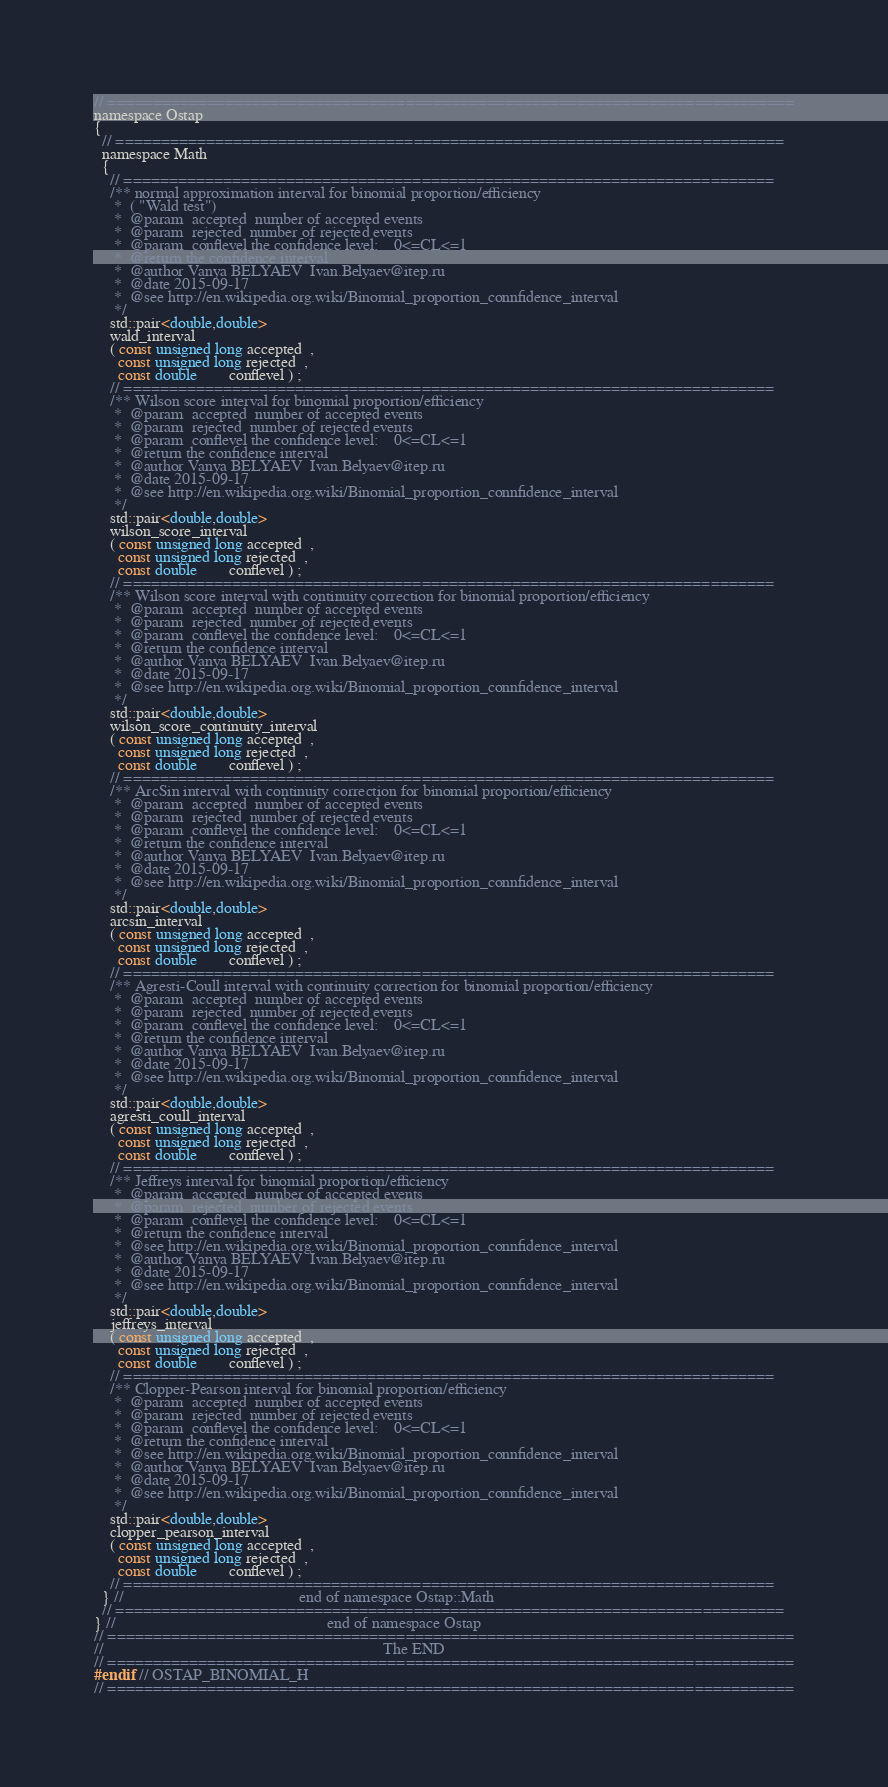Convert code to text. <code><loc_0><loc_0><loc_500><loc_500><_C_>// ============================================================================
namespace Ostap
{
  // ==========================================================================
  namespace Math
  {
    // ========================================================================
    /** normal approximation interval for binomial proportion/efficiency 
     *  ( "Wald test")
     *  @param  accepted  number of accepted events
     *  @param  rejected  number of rejected events
     *  @param  conflevel the confidence level:    0<=CL<=1 
     *  @return the confidence interval 
     *  @author Vanya BELYAEV  Ivan.Belyaev@itep.ru
     *  @date 2015-09-17
     *  @see http://en.wikipedia.org.wiki/Binomial_proportion_connfidence_interval
     */
    std::pair<double,double>
    wald_interval
    ( const unsigned long accepted  ,
      const unsigned long rejected  ,
      const double        conflevel ) ;
    // ========================================================================
    /** Wilson score interval for binomial proportion/efficiency 
     *  @param  accepted  number of accepted events
     *  @param  rejected  number of rejected events
     *  @param  conflevel the confidence level:    0<=CL<=1 
     *  @return the confidence interval 
     *  @author Vanya BELYAEV  Ivan.Belyaev@itep.ru
     *  @date 2015-09-17
     *  @see http://en.wikipedia.org.wiki/Binomial_proportion_connfidence_interval
     */
    std::pair<double,double>
    wilson_score_interval
    ( const unsigned long accepted  ,
      const unsigned long rejected  ,
      const double        conflevel ) ;
    // ========================================================================
    /** Wilson score interval with continuity correction for binomial proportion/efficiency 
     *  @param  accepted  number of accepted events
     *  @param  rejected  number of rejected events
     *  @param  conflevel the confidence level:    0<=CL<=1 
     *  @return the confidence interval 
     *  @author Vanya BELYAEV  Ivan.Belyaev@itep.ru
     *  @date 2015-09-17
     *  @see http://en.wikipedia.org.wiki/Binomial_proportion_connfidence_interval
     */
    std::pair<double,double>
    wilson_score_continuity_interval
    ( const unsigned long accepted  ,
      const unsigned long rejected  ,
      const double        conflevel ) ;
    // ========================================================================
    /** ArcSin interval with continuity correction for binomial proportion/efficiency 
     *  @param  accepted  number of accepted events
     *  @param  rejected  number of rejected events
     *  @param  conflevel the confidence level:    0<=CL<=1 
     *  @return the confidence interval 
     *  @author Vanya BELYAEV  Ivan.Belyaev@itep.ru
     *  @date 2015-09-17
     *  @see http://en.wikipedia.org.wiki/Binomial_proportion_connfidence_interval
     */
    std::pair<double,double>
    arcsin_interval
    ( const unsigned long accepted  ,
      const unsigned long rejected  ,
      const double        conflevel ) ;
    // ========================================================================
    /** Agresti-Coull interval with continuity correction for binomial proportion/efficiency 
     *  @param  accepted  number of accepted events
     *  @param  rejected  number of rejected events
     *  @param  conflevel the confidence level:    0<=CL<=1 
     *  @return the confidence interval 
     *  @author Vanya BELYAEV  Ivan.Belyaev@itep.ru
     *  @date 2015-09-17
     *  @see http://en.wikipedia.org.wiki/Binomial_proportion_connfidence_interval
     */
    std::pair<double,double>
    agresti_coull_interval
    ( const unsigned long accepted  ,
      const unsigned long rejected  ,
      const double        conflevel ) ;
    // ========================================================================
    /** Jeffreys interval for binomial proportion/efficiency 
     *  @param  accepted  number of accepted events
     *  @param  rejected  number of rejected events
     *  @param  conflevel the confidence level:    0<=CL<=1 
     *  @return the confidence interval 
     *  @see http://en.wikipedia.org.wiki/Binomial_proportion_connfidence_interval
     *  @author Vanya BELYAEV  Ivan.Belyaev@itep.ru
     *  @date 2015-09-17
     *  @see http://en.wikipedia.org.wiki/Binomial_proportion_connfidence_interval
     */
    std::pair<double,double>
    jeffreys_interval
    ( const unsigned long accepted  ,
      const unsigned long rejected  ,
      const double        conflevel ) ;
    // ========================================================================
    /** Clopper-Pearson interval for binomial proportion/efficiency 
     *  @param  accepted  number of accepted events
     *  @param  rejected  number of rejected events
     *  @param  conflevel the confidence level:    0<=CL<=1 
     *  @return the confidence interval 
     *  @see http://en.wikipedia.org.wiki/Binomial_proportion_connfidence_interval
     *  @author Vanya BELYAEV  Ivan.Belyaev@itep.ru
     *  @date 2015-09-17
     *  @see http://en.wikipedia.org.wiki/Binomial_proportion_connfidence_interval
     */
    std::pair<double,double>
    clopper_pearson_interval
    ( const unsigned long accepted  ,
      const unsigned long rejected  ,
      const double        conflevel ) ;
    // ========================================================================
  } //                                            end of namespace Ostap::Math
  // ==========================================================================
} //                                                     end of namespace Ostap
// ============================================================================
//                                                                      The END 
// ============================================================================
#endif // OSTAP_BINOMIAL_H
// ============================================================================
</code> 